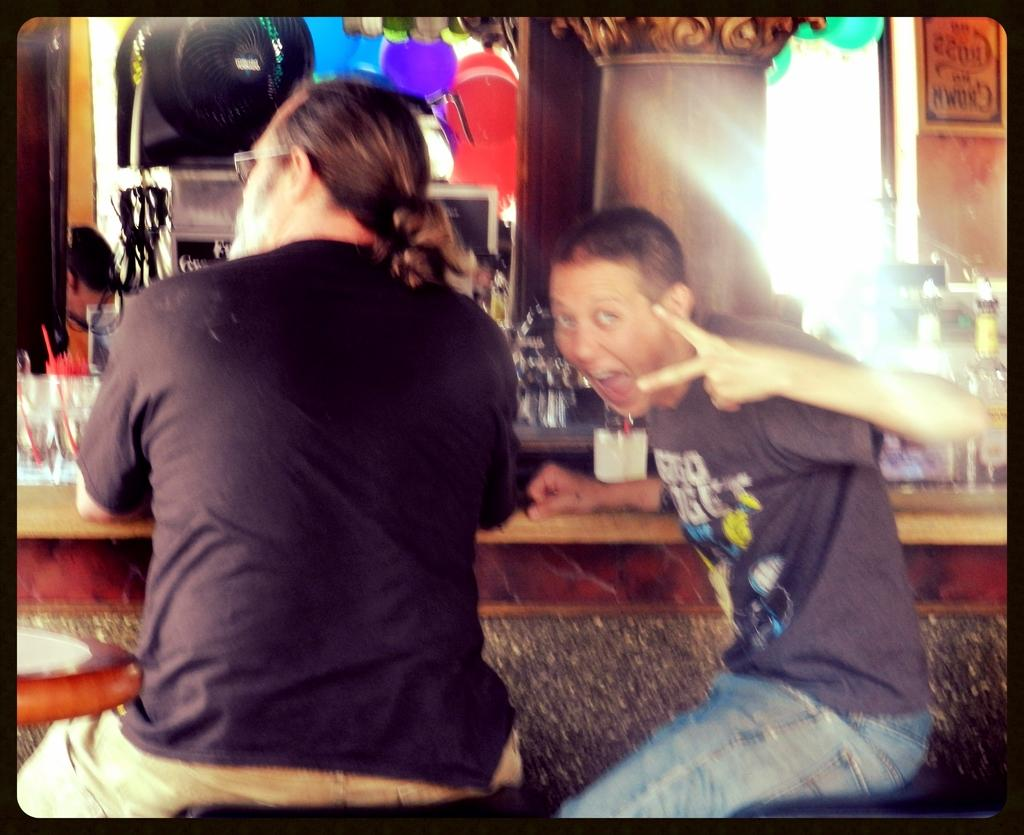How many people are present in the image? There are two people sitting in the image. What objects can be seen on the table in the image? There are glasses and bottles on the table in the image. What type of frame is holding the ground in the image? There is no frame or ground present in the image; it features two people sitting and objects on a table. 